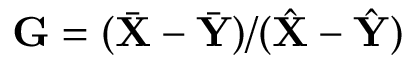Convert formula to latex. <formula><loc_0><loc_0><loc_500><loc_500>\mathbf G = ( \bar { \mathbf X } - \bar { \mathbf Y } ) / ( \hat { \mathbf X } - \hat { \mathbf Y } )</formula> 